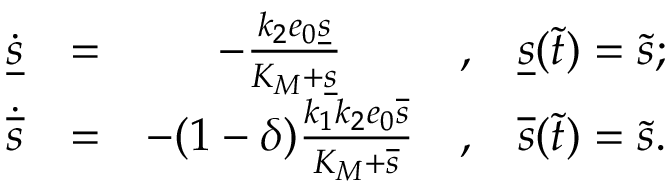Convert formula to latex. <formula><loc_0><loc_0><loc_500><loc_500>\begin{array} { r c c c l } { \dot { \underline { s } } } & { = } & { - \frac { k _ { 2 } e _ { 0 } \underline { s } } { K _ { M } + \underline { s } } } & { , } & { \underline { s } ( \widetilde { t } ) = \widetilde { s } ; } \\ { \dot { \overline { s } } } & { = } & { - ( 1 - \delta ) \frac { k _ { 1 } k _ { 2 } e _ { 0 } \overline { s } } { K _ { M } + \overline { s } } } & { , } & { \overline { s } ( \widetilde { t } ) = \widetilde { s } . } \end{array}</formula> 